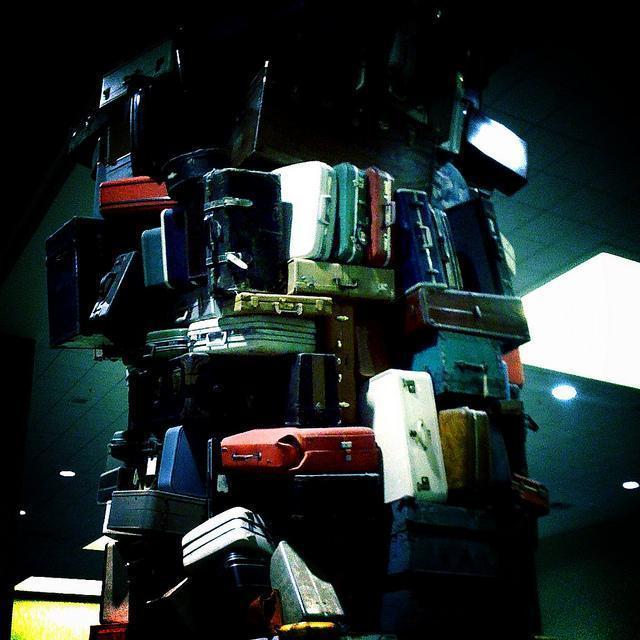How many red cases are there?
Give a very brief answer. 2. How many suitcases are there?
Give a very brief answer. 14. 